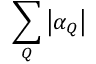<formula> <loc_0><loc_0><loc_500><loc_500>\sum _ { Q } \left | \alpha _ { Q } \right |</formula> 